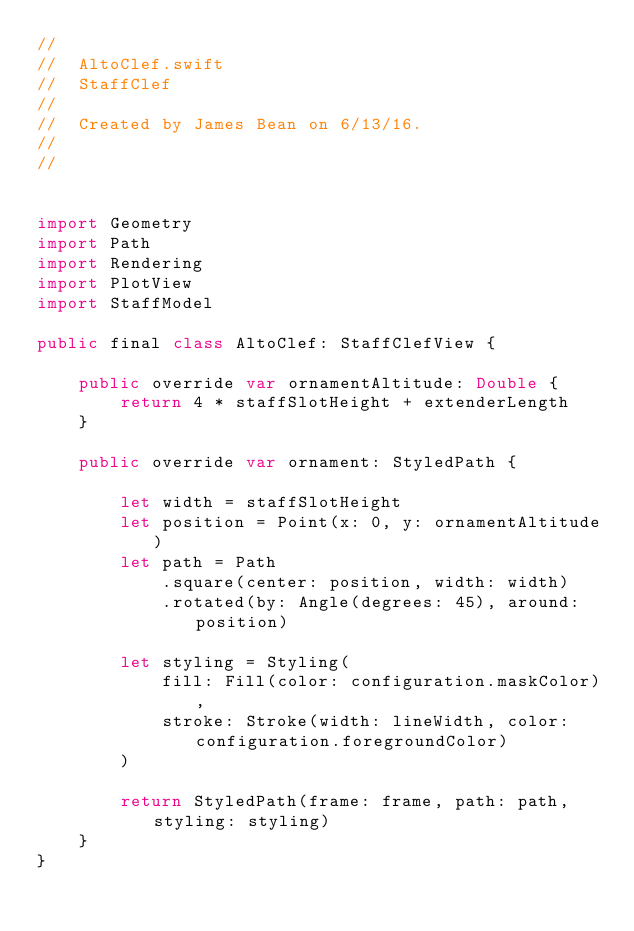Convert code to text. <code><loc_0><loc_0><loc_500><loc_500><_Swift_>//
//  AltoClef.swift
//  StaffClef
//
//  Created by James Bean on 6/13/16.
//
//


import Geometry
import Path
import Rendering
import PlotView
import StaffModel

public final class AltoClef: StaffClefView {
    
    public override var ornamentAltitude: Double {
        return 4 * staffSlotHeight + extenderLength
    }
    
    public override var ornament: StyledPath {
        
        let width = staffSlotHeight
        let position = Point(x: 0, y: ornamentAltitude)
        let path = Path
            .square(center: position, width: width)
            .rotated(by: Angle(degrees: 45), around: position)
        
        let styling = Styling(
            fill: Fill(color: configuration.maskColor),
            stroke: Stroke(width: lineWidth, color: configuration.foregroundColor)
        )
        
        return StyledPath(frame: frame, path: path, styling: styling)
    }
}
</code> 